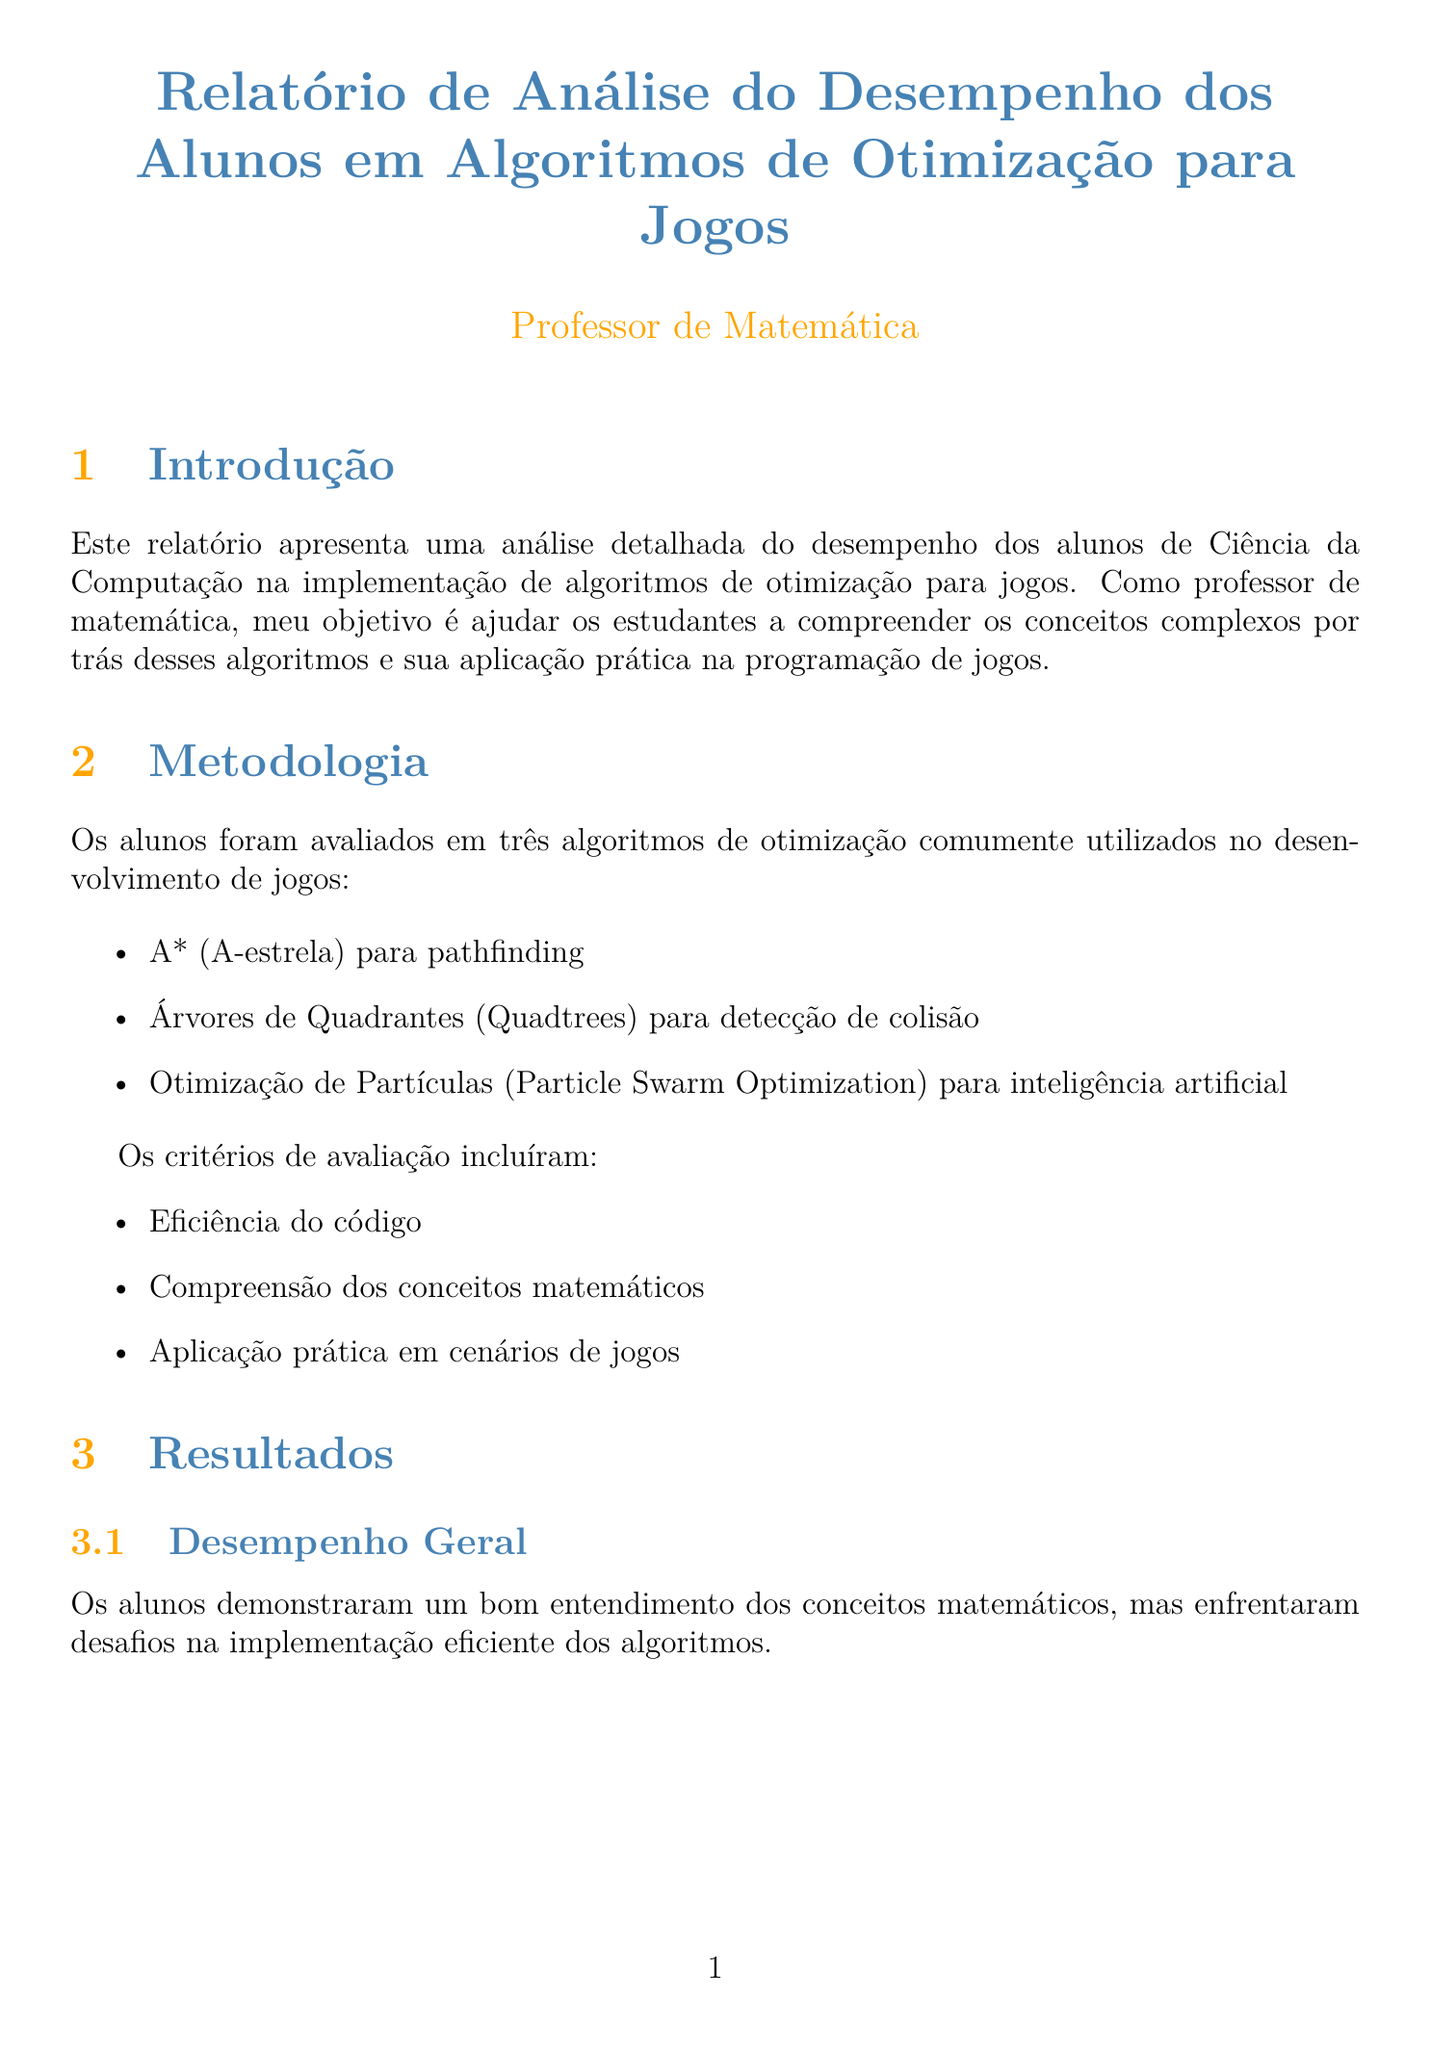Qual o título do relatório? O título do relatório é a primeira informação apresentada no documento.
Answer: Relatório de Análise do Desempenho dos Alunos em Algoritmos de Otimização para Jogos Quais algoritmos foram avaliados? A seção de Metodologia lista os algoritmos usados para avaliação.
Answer: A* (A-estrela), Árvores de Quadrantes, Otimização de Partículas Qual a pontuação média do algoritmo A*? O gráfico comparativo apresenta as pontuações médias dos algoritmos.
Answer: 78 Quais são os pontos fortes do algoritmo de Otimização de Partículas? A análise por algoritmo fornece detalhes sobre pontos fortes e desafios de cada algoritmo.
Answer: Entendimento do conceito de busca global Quais recomendações foram feitas para reforço em estruturas de dados? As recomendações listadas oferecem sugestões específicas para melhorar a implementação de algoritmos.
Answer: Realizar exercícios práticos focados em heap binário e listas de adjacência Quantas recomendações são apresentadas no relatório? A seção de Recomendações contém uma lista enumerada de sugestões.
Answer: Quatro O que os alunos demonstraram em relação à compreensão de algoritmos? A conclusão resume a performance dos alunos em relação à compreensão dos algoritmos.
Answer: Progresso significativo Qual é o autor do livro recomendado? A seção de Recursos Adicionais lista o autor do livro.
Answer: Fletcher Dunn e Ian Parberry 